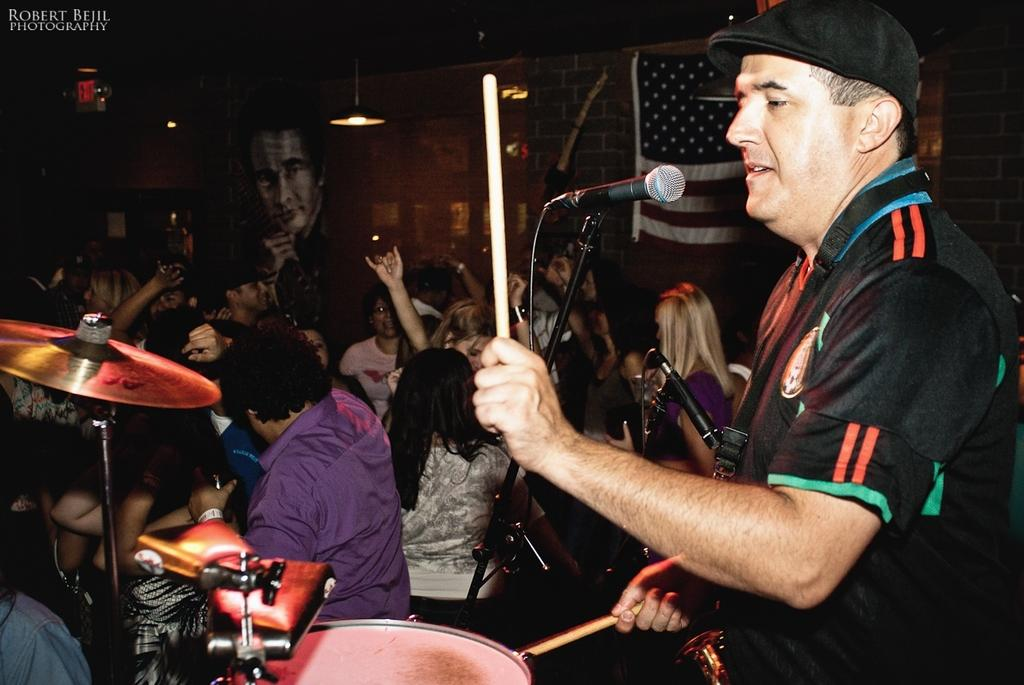Who is the person in the image? There is a man in the image. What is the man doing in the image? The man is playing drums. What object is present for amplifying sound in the image? There is a microphone (mike) in the image. What other musical instruments can be seen in the image? There are musical instruments in the image. What type of lighting is present in the image? There is a light in the image. How many beds are visible in the image? There are no beds present in the image. What type of letters can be seen on the musical instruments in the image? There are no letters visible on the musical instruments in the image. 